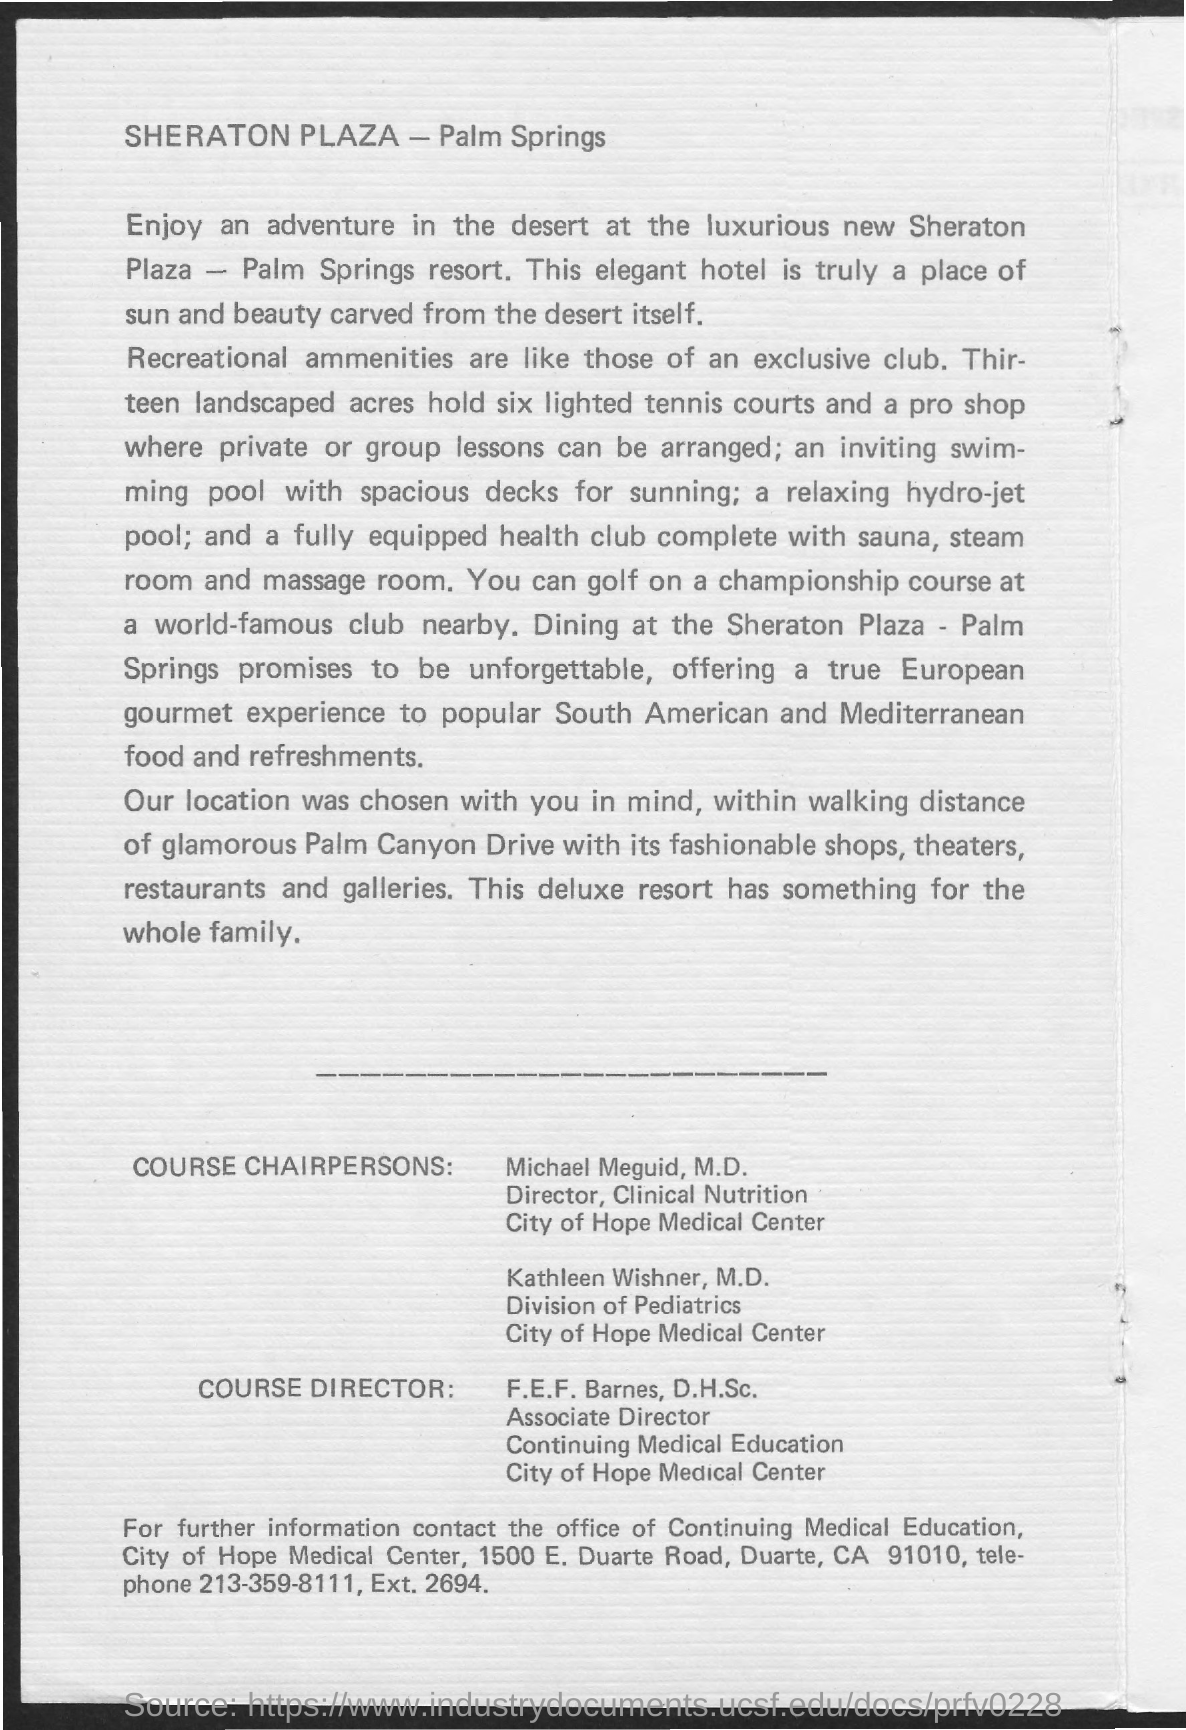What is the name of director , clinical nutrition ?
Your answer should be very brief. Michael Meguid, M.D. Who is the associate director of continuing medical education?
Offer a very short reply. F.E.F. Barnes, D.H.Sc. What is the telephone for further information?
Your response must be concise. 213-359-8111. 